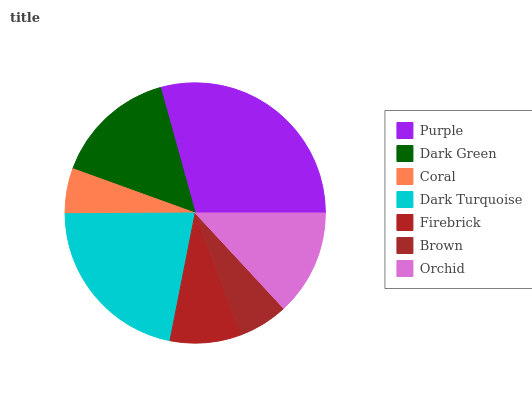Is Coral the minimum?
Answer yes or no. Yes. Is Purple the maximum?
Answer yes or no. Yes. Is Dark Green the minimum?
Answer yes or no. No. Is Dark Green the maximum?
Answer yes or no. No. Is Purple greater than Dark Green?
Answer yes or no. Yes. Is Dark Green less than Purple?
Answer yes or no. Yes. Is Dark Green greater than Purple?
Answer yes or no. No. Is Purple less than Dark Green?
Answer yes or no. No. Is Orchid the high median?
Answer yes or no. Yes. Is Orchid the low median?
Answer yes or no. Yes. Is Brown the high median?
Answer yes or no. No. Is Purple the low median?
Answer yes or no. No. 